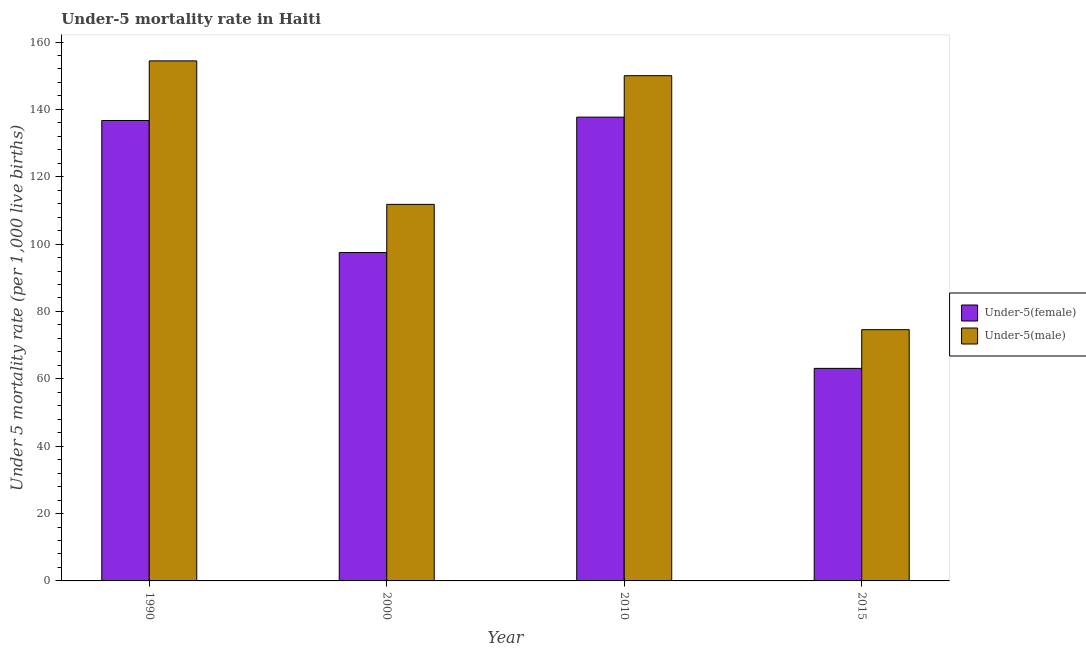How many different coloured bars are there?
Give a very brief answer. 2. How many groups of bars are there?
Make the answer very short. 4. Are the number of bars per tick equal to the number of legend labels?
Offer a terse response. Yes. Are the number of bars on each tick of the X-axis equal?
Your answer should be very brief. Yes. What is the under-5 male mortality rate in 2000?
Make the answer very short. 111.8. Across all years, what is the maximum under-5 female mortality rate?
Your response must be concise. 137.7. Across all years, what is the minimum under-5 male mortality rate?
Give a very brief answer. 74.6. In which year was the under-5 female mortality rate minimum?
Ensure brevity in your answer.  2015. What is the total under-5 male mortality rate in the graph?
Give a very brief answer. 490.8. What is the difference between the under-5 female mortality rate in 1990 and that in 2010?
Your response must be concise. -1. What is the difference between the under-5 female mortality rate in 2015 and the under-5 male mortality rate in 1990?
Offer a very short reply. -73.6. What is the average under-5 male mortality rate per year?
Provide a succinct answer. 122.7. What is the ratio of the under-5 female mortality rate in 2000 to that in 2010?
Offer a very short reply. 0.71. Is the under-5 male mortality rate in 2000 less than that in 2010?
Give a very brief answer. Yes. What is the difference between the highest and the second highest under-5 male mortality rate?
Provide a short and direct response. 4.4. What is the difference between the highest and the lowest under-5 female mortality rate?
Keep it short and to the point. 74.6. What does the 1st bar from the left in 2000 represents?
Keep it short and to the point. Under-5(female). What does the 2nd bar from the right in 1990 represents?
Make the answer very short. Under-5(female). Are all the bars in the graph horizontal?
Offer a very short reply. No. How many years are there in the graph?
Your answer should be compact. 4. What is the difference between two consecutive major ticks on the Y-axis?
Keep it short and to the point. 20. Are the values on the major ticks of Y-axis written in scientific E-notation?
Your response must be concise. No. Does the graph contain grids?
Your answer should be very brief. No. What is the title of the graph?
Provide a succinct answer. Under-5 mortality rate in Haiti. Does "Merchandise imports" appear as one of the legend labels in the graph?
Your answer should be compact. No. What is the label or title of the Y-axis?
Provide a short and direct response. Under 5 mortality rate (per 1,0 live births). What is the Under 5 mortality rate (per 1,000 live births) of Under-5(female) in 1990?
Make the answer very short. 136.7. What is the Under 5 mortality rate (per 1,000 live births) of Under-5(male) in 1990?
Provide a succinct answer. 154.4. What is the Under 5 mortality rate (per 1,000 live births) in Under-5(female) in 2000?
Your answer should be very brief. 97.5. What is the Under 5 mortality rate (per 1,000 live births) in Under-5(male) in 2000?
Offer a terse response. 111.8. What is the Under 5 mortality rate (per 1,000 live births) of Under-5(female) in 2010?
Offer a very short reply. 137.7. What is the Under 5 mortality rate (per 1,000 live births) in Under-5(male) in 2010?
Offer a terse response. 150. What is the Under 5 mortality rate (per 1,000 live births) of Under-5(female) in 2015?
Your answer should be very brief. 63.1. What is the Under 5 mortality rate (per 1,000 live births) in Under-5(male) in 2015?
Keep it short and to the point. 74.6. Across all years, what is the maximum Under 5 mortality rate (per 1,000 live births) in Under-5(female)?
Your response must be concise. 137.7. Across all years, what is the maximum Under 5 mortality rate (per 1,000 live births) in Under-5(male)?
Offer a terse response. 154.4. Across all years, what is the minimum Under 5 mortality rate (per 1,000 live births) of Under-5(female)?
Ensure brevity in your answer.  63.1. Across all years, what is the minimum Under 5 mortality rate (per 1,000 live births) of Under-5(male)?
Keep it short and to the point. 74.6. What is the total Under 5 mortality rate (per 1,000 live births) in Under-5(female) in the graph?
Provide a succinct answer. 435. What is the total Under 5 mortality rate (per 1,000 live births) in Under-5(male) in the graph?
Give a very brief answer. 490.8. What is the difference between the Under 5 mortality rate (per 1,000 live births) in Under-5(female) in 1990 and that in 2000?
Ensure brevity in your answer.  39.2. What is the difference between the Under 5 mortality rate (per 1,000 live births) of Under-5(male) in 1990 and that in 2000?
Your response must be concise. 42.6. What is the difference between the Under 5 mortality rate (per 1,000 live births) in Under-5(female) in 1990 and that in 2010?
Provide a succinct answer. -1. What is the difference between the Under 5 mortality rate (per 1,000 live births) in Under-5(male) in 1990 and that in 2010?
Provide a short and direct response. 4.4. What is the difference between the Under 5 mortality rate (per 1,000 live births) in Under-5(female) in 1990 and that in 2015?
Your response must be concise. 73.6. What is the difference between the Under 5 mortality rate (per 1,000 live births) in Under-5(male) in 1990 and that in 2015?
Your answer should be very brief. 79.8. What is the difference between the Under 5 mortality rate (per 1,000 live births) in Under-5(female) in 2000 and that in 2010?
Make the answer very short. -40.2. What is the difference between the Under 5 mortality rate (per 1,000 live births) in Under-5(male) in 2000 and that in 2010?
Ensure brevity in your answer.  -38.2. What is the difference between the Under 5 mortality rate (per 1,000 live births) of Under-5(female) in 2000 and that in 2015?
Keep it short and to the point. 34.4. What is the difference between the Under 5 mortality rate (per 1,000 live births) in Under-5(male) in 2000 and that in 2015?
Provide a short and direct response. 37.2. What is the difference between the Under 5 mortality rate (per 1,000 live births) in Under-5(female) in 2010 and that in 2015?
Offer a terse response. 74.6. What is the difference between the Under 5 mortality rate (per 1,000 live births) in Under-5(male) in 2010 and that in 2015?
Give a very brief answer. 75.4. What is the difference between the Under 5 mortality rate (per 1,000 live births) in Under-5(female) in 1990 and the Under 5 mortality rate (per 1,000 live births) in Under-5(male) in 2000?
Offer a very short reply. 24.9. What is the difference between the Under 5 mortality rate (per 1,000 live births) in Under-5(female) in 1990 and the Under 5 mortality rate (per 1,000 live births) in Under-5(male) in 2015?
Provide a succinct answer. 62.1. What is the difference between the Under 5 mortality rate (per 1,000 live births) in Under-5(female) in 2000 and the Under 5 mortality rate (per 1,000 live births) in Under-5(male) in 2010?
Ensure brevity in your answer.  -52.5. What is the difference between the Under 5 mortality rate (per 1,000 live births) in Under-5(female) in 2000 and the Under 5 mortality rate (per 1,000 live births) in Under-5(male) in 2015?
Your response must be concise. 22.9. What is the difference between the Under 5 mortality rate (per 1,000 live births) of Under-5(female) in 2010 and the Under 5 mortality rate (per 1,000 live births) of Under-5(male) in 2015?
Give a very brief answer. 63.1. What is the average Under 5 mortality rate (per 1,000 live births) of Under-5(female) per year?
Make the answer very short. 108.75. What is the average Under 5 mortality rate (per 1,000 live births) of Under-5(male) per year?
Make the answer very short. 122.7. In the year 1990, what is the difference between the Under 5 mortality rate (per 1,000 live births) of Under-5(female) and Under 5 mortality rate (per 1,000 live births) of Under-5(male)?
Ensure brevity in your answer.  -17.7. In the year 2000, what is the difference between the Under 5 mortality rate (per 1,000 live births) of Under-5(female) and Under 5 mortality rate (per 1,000 live births) of Under-5(male)?
Make the answer very short. -14.3. In the year 2010, what is the difference between the Under 5 mortality rate (per 1,000 live births) of Under-5(female) and Under 5 mortality rate (per 1,000 live births) of Under-5(male)?
Make the answer very short. -12.3. In the year 2015, what is the difference between the Under 5 mortality rate (per 1,000 live births) in Under-5(female) and Under 5 mortality rate (per 1,000 live births) in Under-5(male)?
Your answer should be very brief. -11.5. What is the ratio of the Under 5 mortality rate (per 1,000 live births) in Under-5(female) in 1990 to that in 2000?
Your answer should be very brief. 1.4. What is the ratio of the Under 5 mortality rate (per 1,000 live births) of Under-5(male) in 1990 to that in 2000?
Your response must be concise. 1.38. What is the ratio of the Under 5 mortality rate (per 1,000 live births) in Under-5(male) in 1990 to that in 2010?
Your answer should be very brief. 1.03. What is the ratio of the Under 5 mortality rate (per 1,000 live births) of Under-5(female) in 1990 to that in 2015?
Provide a short and direct response. 2.17. What is the ratio of the Under 5 mortality rate (per 1,000 live births) of Under-5(male) in 1990 to that in 2015?
Offer a terse response. 2.07. What is the ratio of the Under 5 mortality rate (per 1,000 live births) in Under-5(female) in 2000 to that in 2010?
Make the answer very short. 0.71. What is the ratio of the Under 5 mortality rate (per 1,000 live births) in Under-5(male) in 2000 to that in 2010?
Keep it short and to the point. 0.75. What is the ratio of the Under 5 mortality rate (per 1,000 live births) of Under-5(female) in 2000 to that in 2015?
Your response must be concise. 1.55. What is the ratio of the Under 5 mortality rate (per 1,000 live births) of Under-5(male) in 2000 to that in 2015?
Ensure brevity in your answer.  1.5. What is the ratio of the Under 5 mortality rate (per 1,000 live births) in Under-5(female) in 2010 to that in 2015?
Make the answer very short. 2.18. What is the ratio of the Under 5 mortality rate (per 1,000 live births) in Under-5(male) in 2010 to that in 2015?
Your answer should be compact. 2.01. What is the difference between the highest and the second highest Under 5 mortality rate (per 1,000 live births) of Under-5(male)?
Keep it short and to the point. 4.4. What is the difference between the highest and the lowest Under 5 mortality rate (per 1,000 live births) of Under-5(female)?
Give a very brief answer. 74.6. What is the difference between the highest and the lowest Under 5 mortality rate (per 1,000 live births) of Under-5(male)?
Your response must be concise. 79.8. 